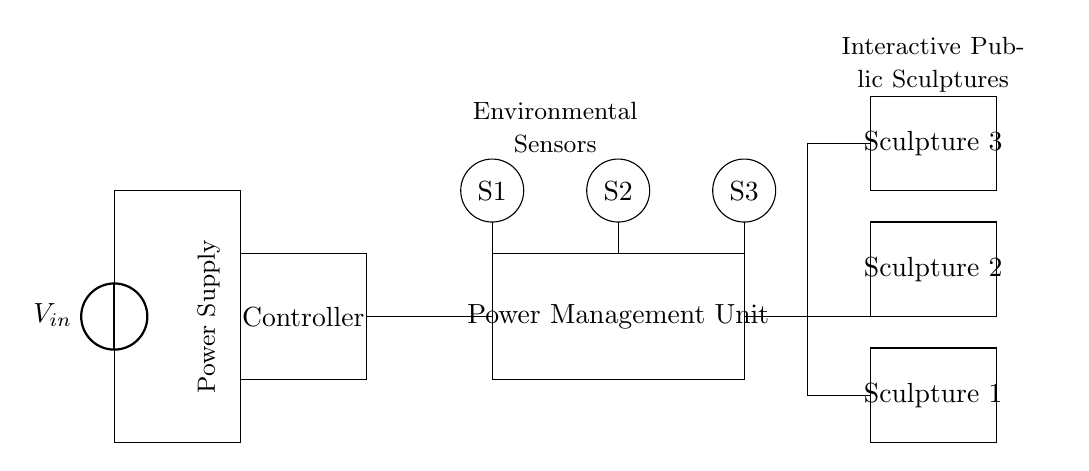What is the input voltage of the circuit? The input voltage is indicated by the source symbol labeled V_in in the diagram, which is connected to the top of the circuit.
Answer: V_in How many interactive sculptures are connected to the power management unit? The circuit diagram shows three rectangles labeled as Sculpture 1, Sculpture 2, and Sculpture 3 connected to the power management unit, indicating that three sculptures are present.
Answer: Three What is the role of the controller in this circuit? The controller, represented by the rectangle labeled 'Controller', manages the power and decisions related to the operation of the interactive sculptures by receiving inputs from the sensors.
Answer: Manage power What connects the environmental sensors to the power management unit? The connection is indicated by solid lines in the diagram that show direct paths from each sensor (S1, S2, S3) to the power management unit, demonstrating that these sensors communicate their data to the unit.
Answer: Solid lines What component measures the environmental conditions? The environmental conditions are measured by the sensors represented by circles labeled S1, S2, and S3, which collect data to inform the controller and power management unit.
Answer: Sensors Which component receives power directly from the voltage source? The voltage source connects directly to the main controller, as shown by the lines leading from the power source to the controller rectangle, indicating that the controller is powered by the voltage source.
Answer: Controller 